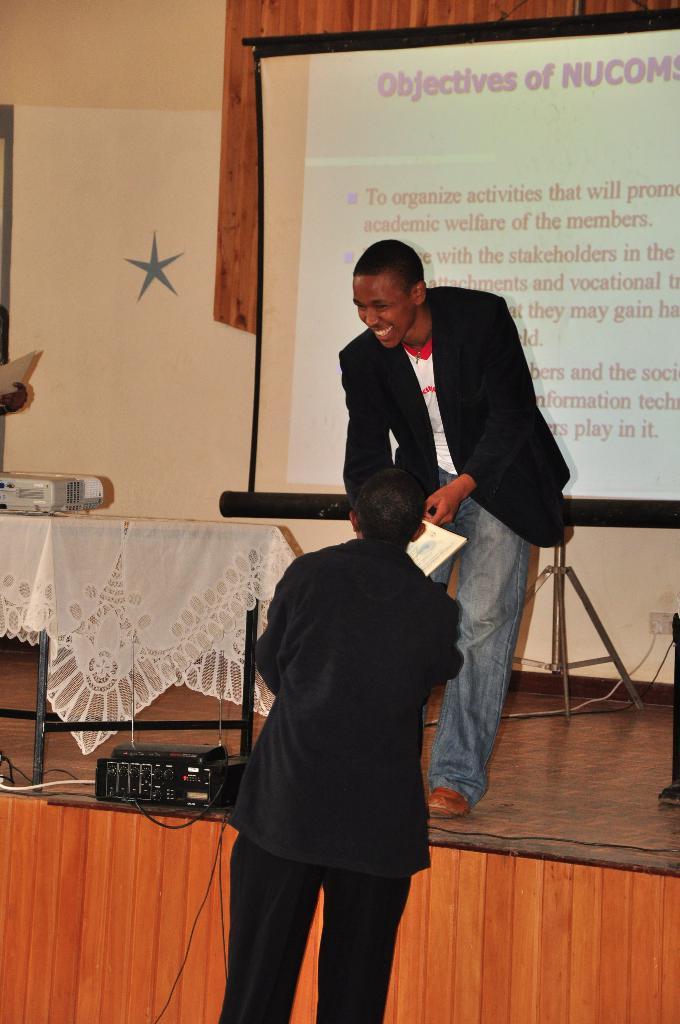In one or two sentences, can you explain what this image depicts? Here two men are standing, this is screen, these are cables, this is wall. 